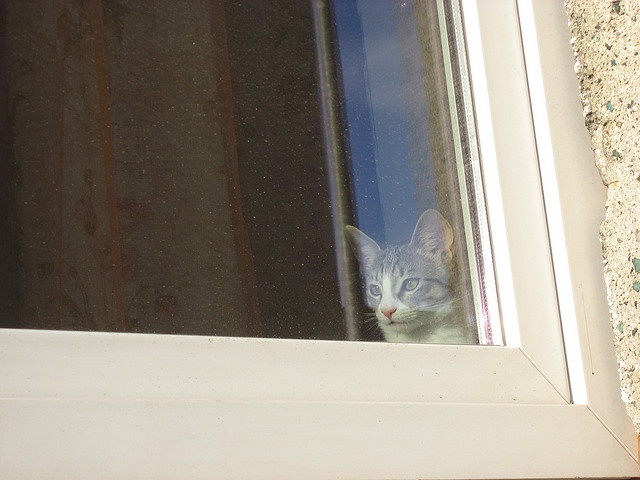Describe the objects in this image and their specific colors. I can see a cat in black, darkgray, and gray tones in this image. 